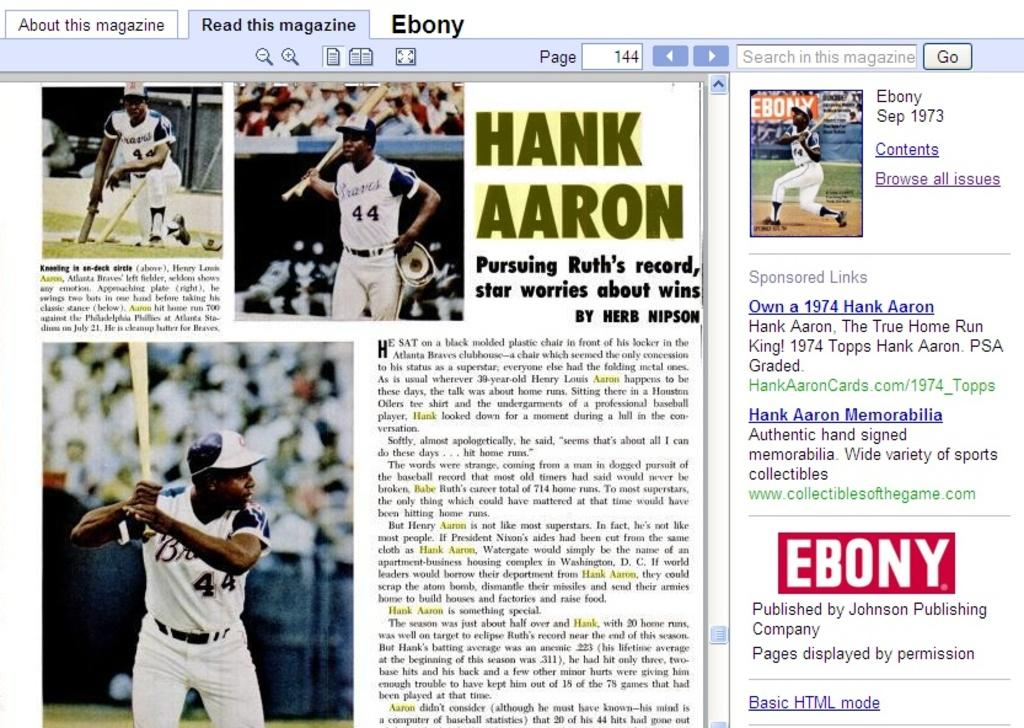Provide a one-sentence caption for the provided image. a picture of a page out of a magzine showing an article of hank aaron. 